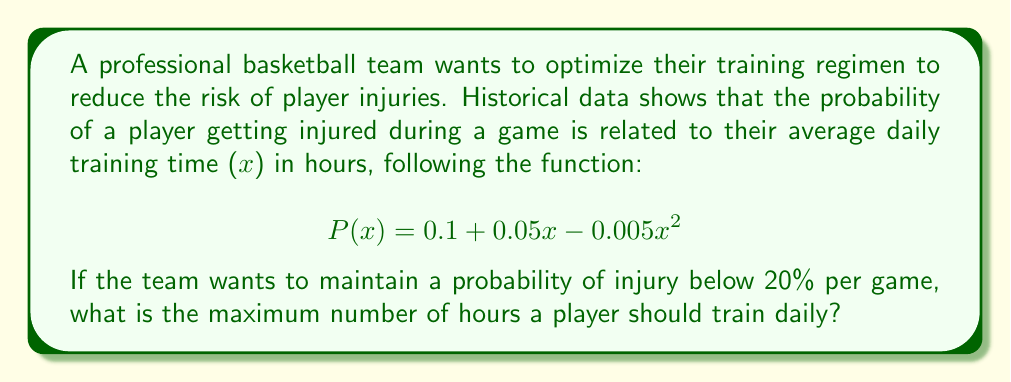Solve this math problem. To solve this problem, we need to follow these steps:

1) The constraint is that the probability of injury should be below 20%, or 0.2. So we need to solve the inequality:

   $$P(x) < 0.2$$

2) Substituting the given function:

   $$0.1 + 0.05x - 0.005x^2 < 0.2$$

3) Rearranging the inequality:

   $$-0.005x^2 + 0.05x - 0.1 < 0$$

4) This is a quadratic inequality. To solve it, we first need to find the roots of the corresponding quadratic equation:

   $$-0.005x^2 + 0.05x - 0.1 = 0$$

5) We can solve this using the quadratic formula: $x = \frac{-b \pm \sqrt{b^2 - 4ac}}{2a}$

   Where $a = -0.005$, $b = 0.05$, and $c = -0.1$

6) Plugging these values into the quadratic formula:

   $$x = \frac{-0.05 \pm \sqrt{0.05^2 - 4(-0.005)(-0.1)}}{2(-0.005)}$$

7) Simplifying:

   $$x = \frac{-0.05 \pm \sqrt{0.0025 - 0.002}}{-0.01} = \frac{-0.05 \pm \sqrt{0.0005}}{-0.01}$$

8) Calculating:

   $$x \approx 1.37 \text{ or } x \approx 8.63$$

9) The inequality is satisfied when $x$ is between these two roots. Since we're looking for the maximum number of hours, we round down 8.63 to the nearest integer.
Answer: The maximum number of hours a player should train daily is 8 hours. 